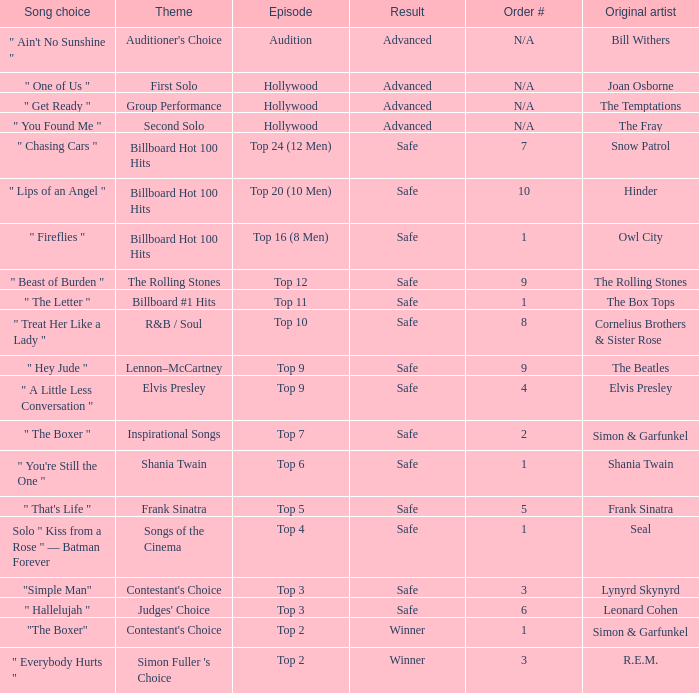The song choice " One of Us " has what themes? First Solo. 